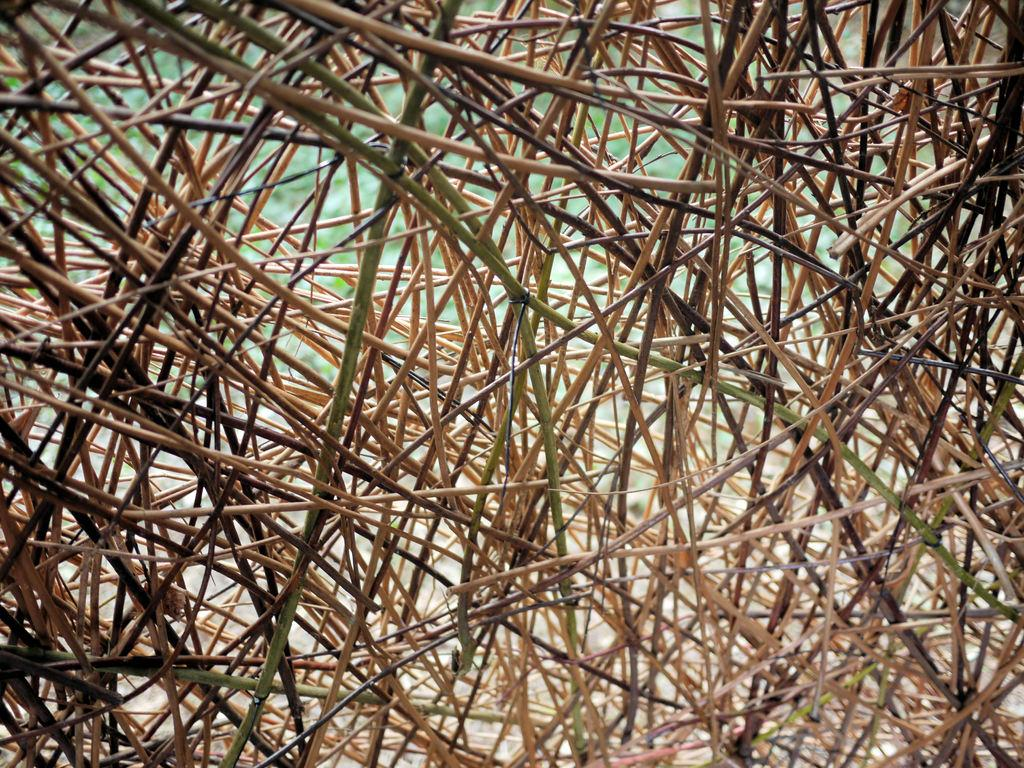What type of vegetation is visible in the foreground of the image? There is grass and plants in the foreground of the image. Can you describe the texture of the grass in the image? The texture of the grass cannot be determined from the image alone. What other elements might be present in the foreground of the image? Based on the provided facts, we can only confirm the presence of grass and plants in the foreground. What type of reasoning is used by the plants in the image? There is no indication in the image that the plants are using any type of reasoning. Can you describe the acoustics of the grass in the image? The acoustics of the grass cannot be determined from the image alone, as it is a visual medium. 